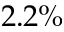Convert formula to latex. <formula><loc_0><loc_0><loc_500><loc_500>2 . 2 \%</formula> 